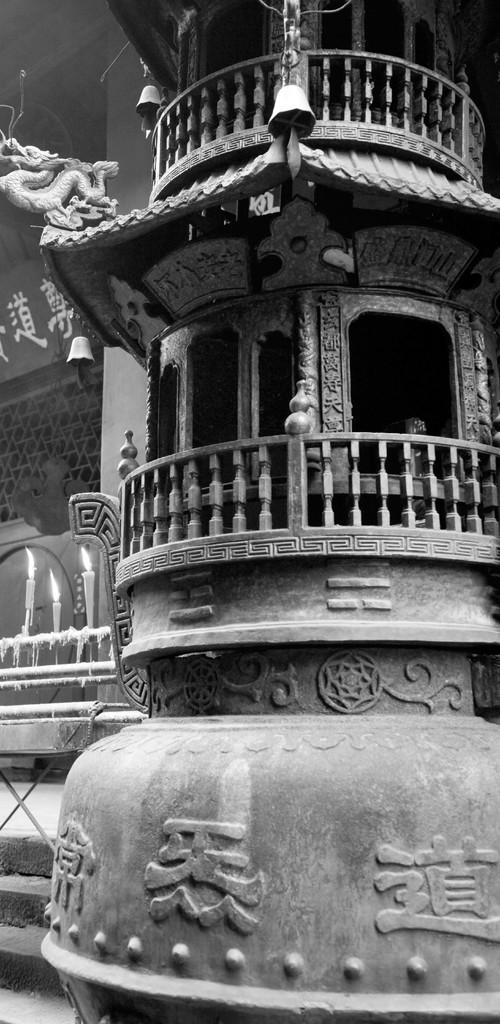How would you summarize this image in a sentence or two? There is an architecture on the right side of the image and there are candles, pipes and net wall on the left side. 